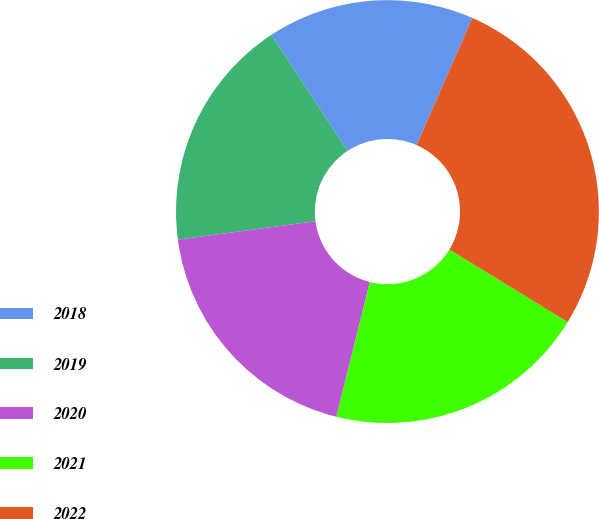Convert chart to OTSL. <chart><loc_0><loc_0><loc_500><loc_500><pie_chart><fcel>2018<fcel>2019<fcel>2020<fcel>2021<fcel>2022<nl><fcel>15.83%<fcel>17.87%<fcel>19.0%<fcel>20.13%<fcel>27.17%<nl></chart> 